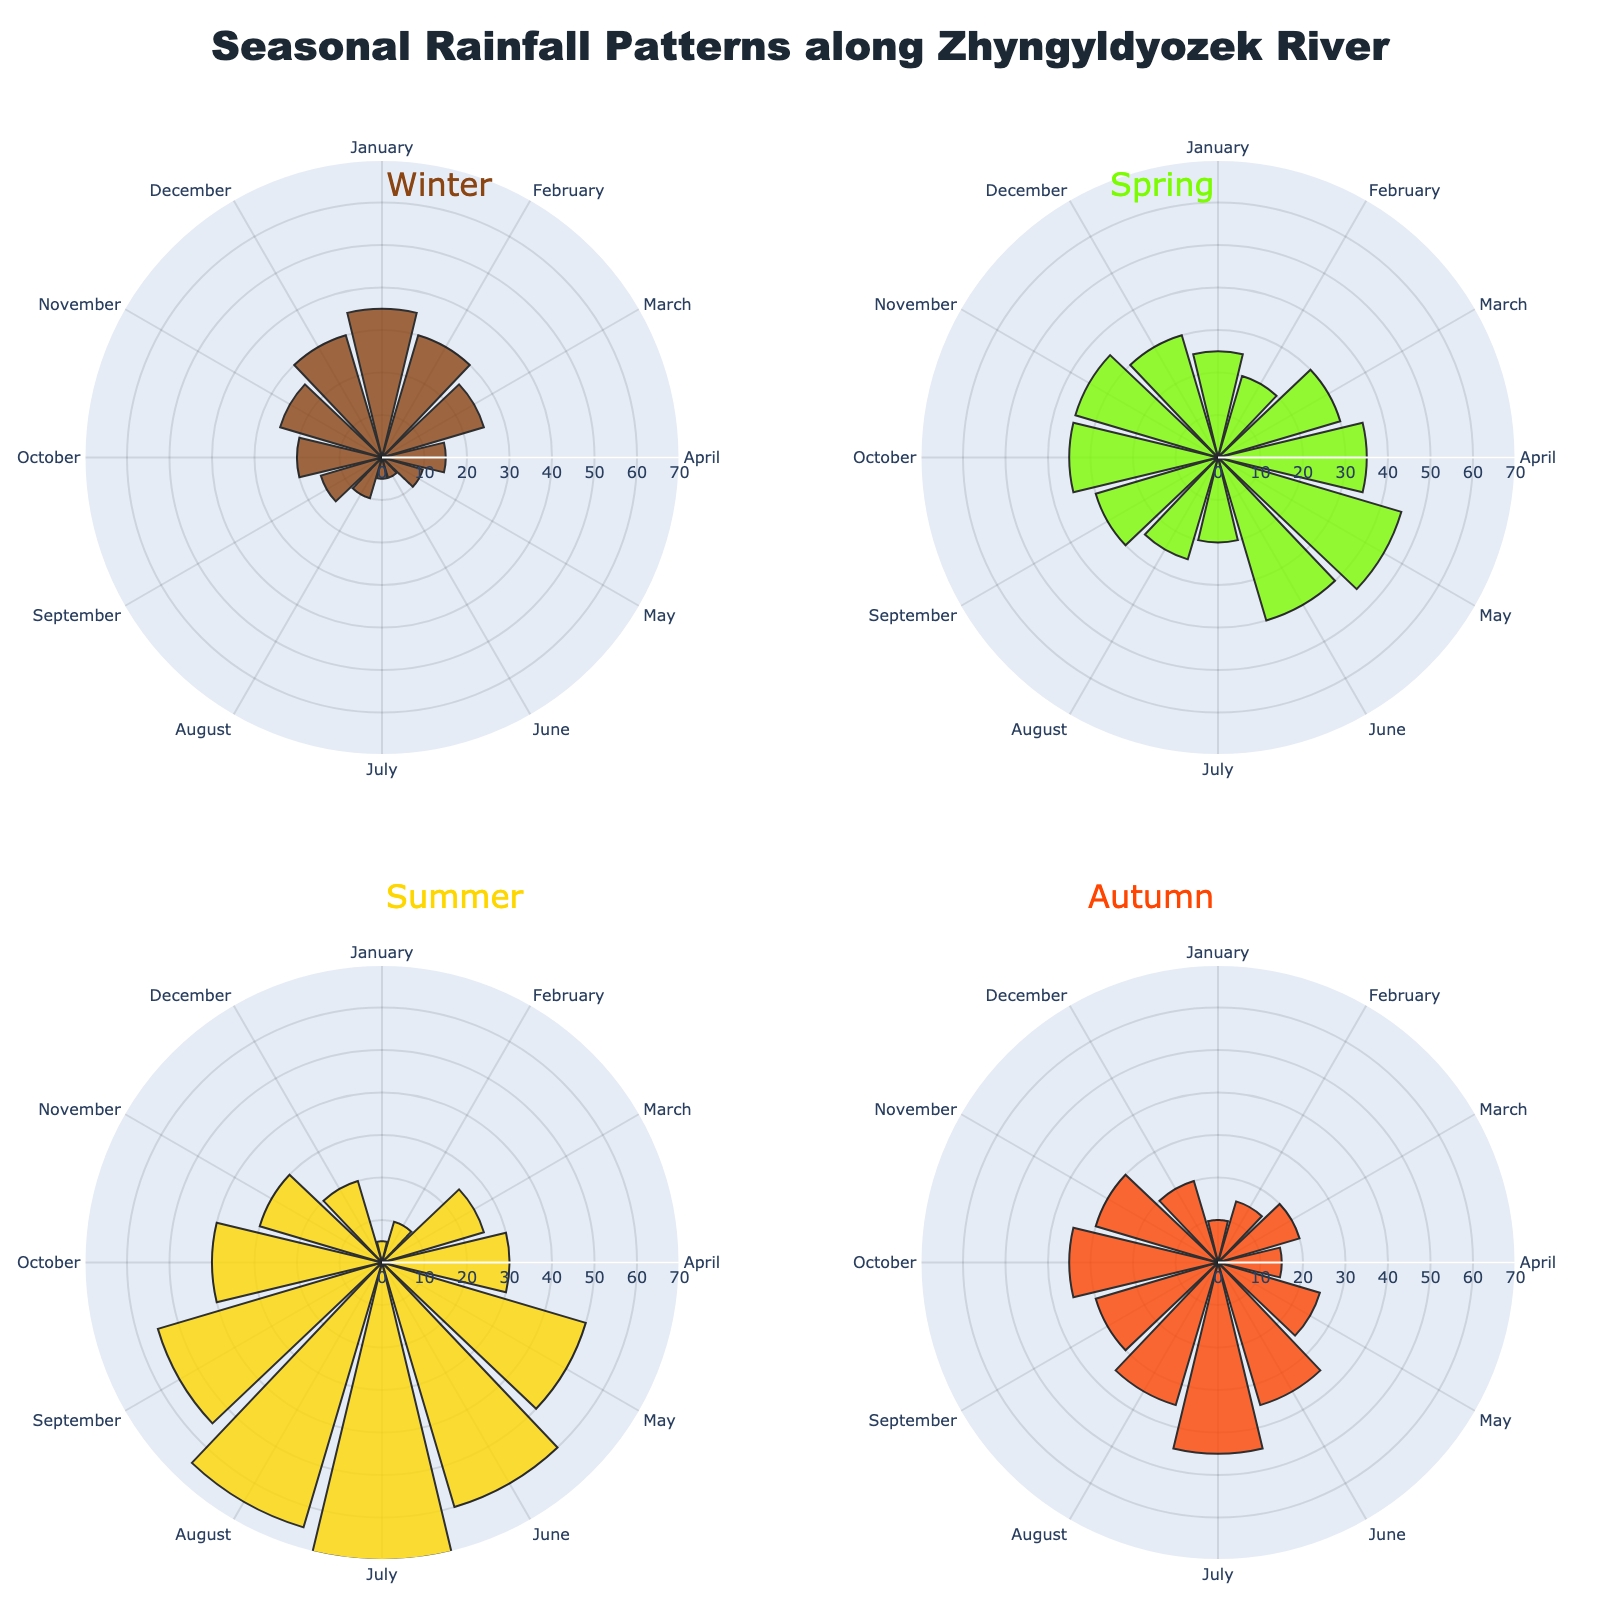What's the title of the figure? The title of the figure is usually displayed prominently at the top. Here, it should describe the overall theme of the data being visualized. The title reads "Seasonal Rainfall Patterns along Zhyngyldyozek River".
Answer: Seasonal Rainfall Patterns along Zhyngyldyozek River Which season shows the highest rainfall in July? Referring to the Summer subplot, July has the highest `r` value. The green bar corresponds to Summer and is the tallest.
Answer: Summer Which season consistently shows low rainfall throughout the year? By comparing the lengths of the bars in all subplots, Winter consistently has the shortest bars suggesting the lowest rainfall values across the months.
Answer: Winter What is the rainfall value for Winter in January? Look at the Winter subplot for January. The radial height of the bar for January in the Winter subplot is labeled 35 mm.
Answer: 35 mm Which season shows the largest increase in rainfall from January to July? By checking the heights of the bars between January and July for each subplot, Summer shows a significant increase from 5 mm to 70 mm.
Answer: Summer What month has the highest rainfall in Spring? By checking the Spring subplot, the bar for May is at its peak, indicating the highest rainfall.
Answer: May Compare rainfall in Autumn and Winter for September. Look at the Autumn subplot for September where the height is 30 mm, and in the Winter subplot it is 15 mm. Autumn has more rainfall in September compared to Winter.
Answer: Autumn Calculate the average monthly rainfall for Spring from March to May. Sum the values: 30 mm (March) + 35 mm (April) + 45 mm (May) = 110 mm. Then average: 110 mm / 3 = 36.67 mm.
Answer: 36.67 mm What is the difference in rainfall between July and December for Summer? Check Summer subplot heights for July (70 mm) and December (20 mm). Difference: 70 mm - 20 mm = 50 mm.
Answer: 50 mm Which season has the smallest variance in monthly rainfall? Visually compare the consistency of bar lengths in each subplot; Spring and Summer vary more, while Winter and Autumn are more consistent. Winter appears to have the smallest variance.
Answer: Winter 